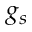<formula> <loc_0><loc_0><loc_500><loc_500>g _ { s }</formula> 